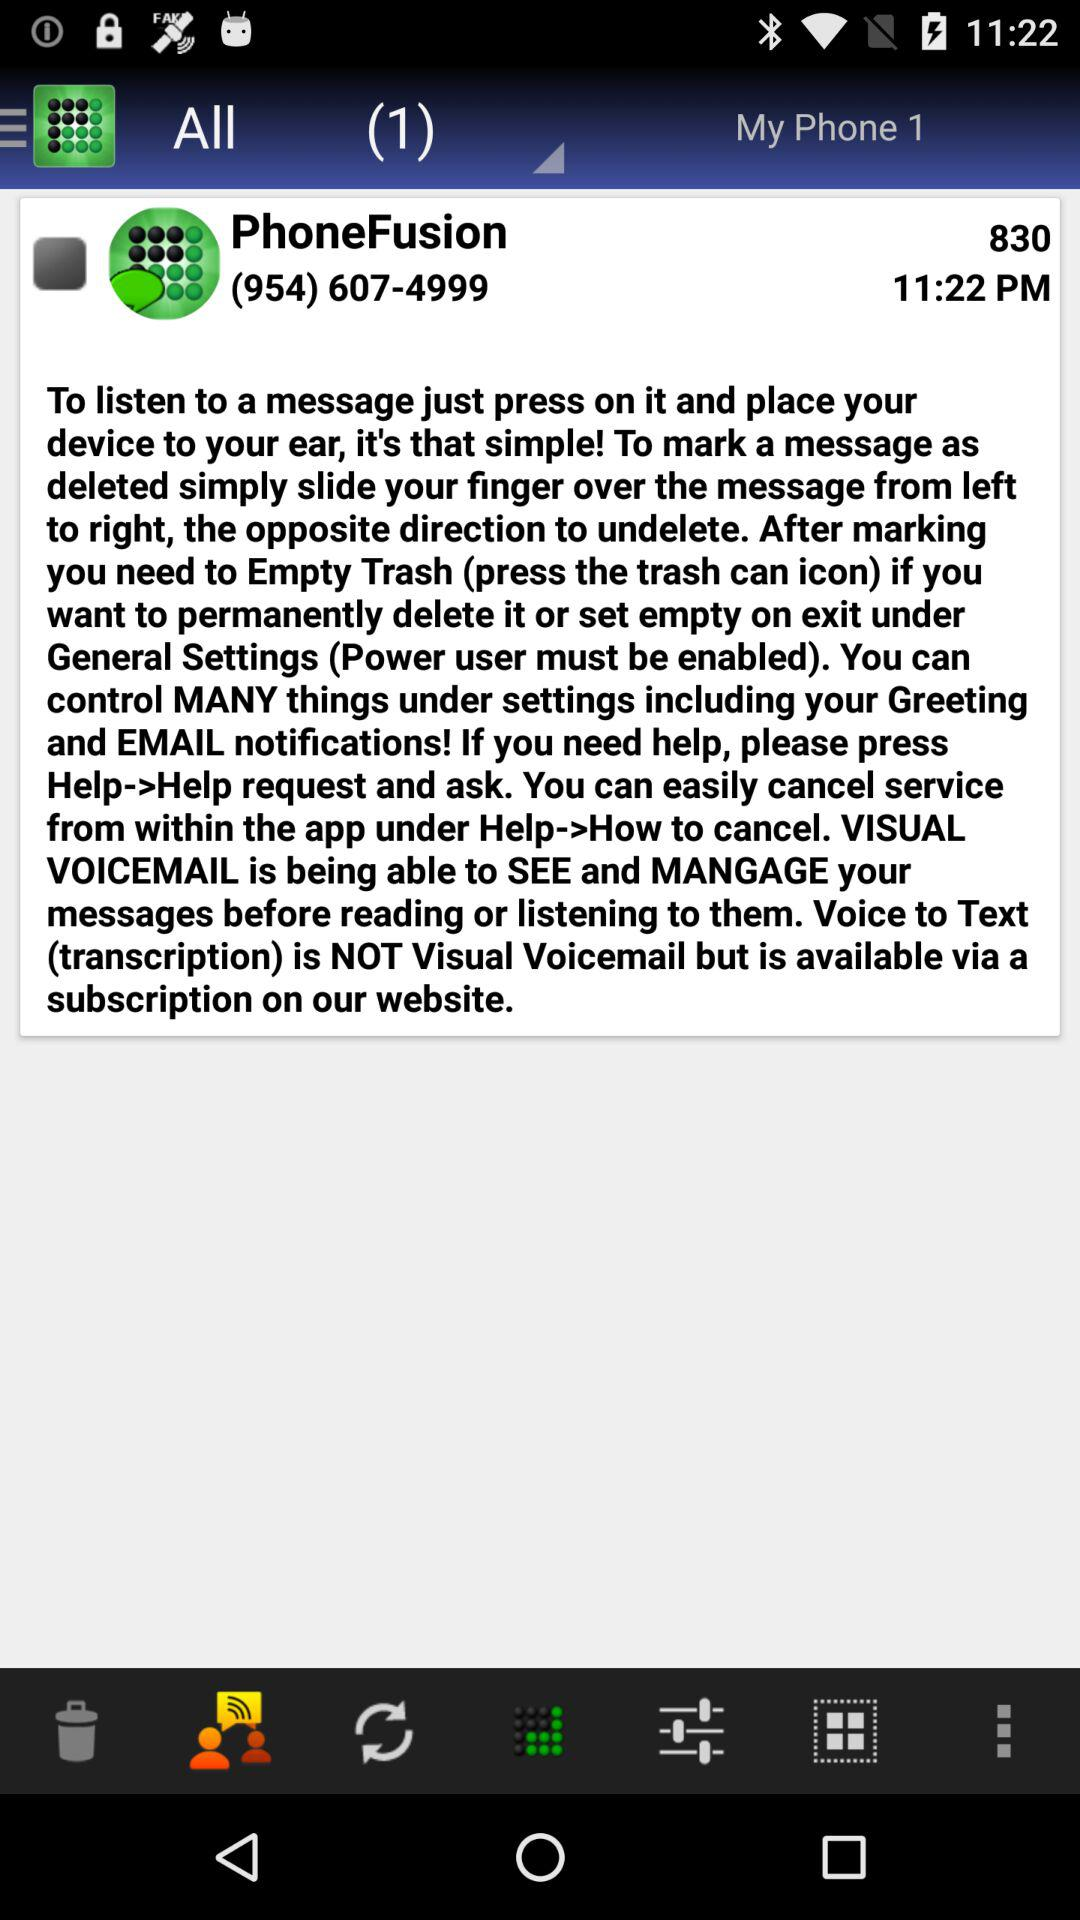How many messages are in the trash?
Answer the question using a single word or phrase. 0 